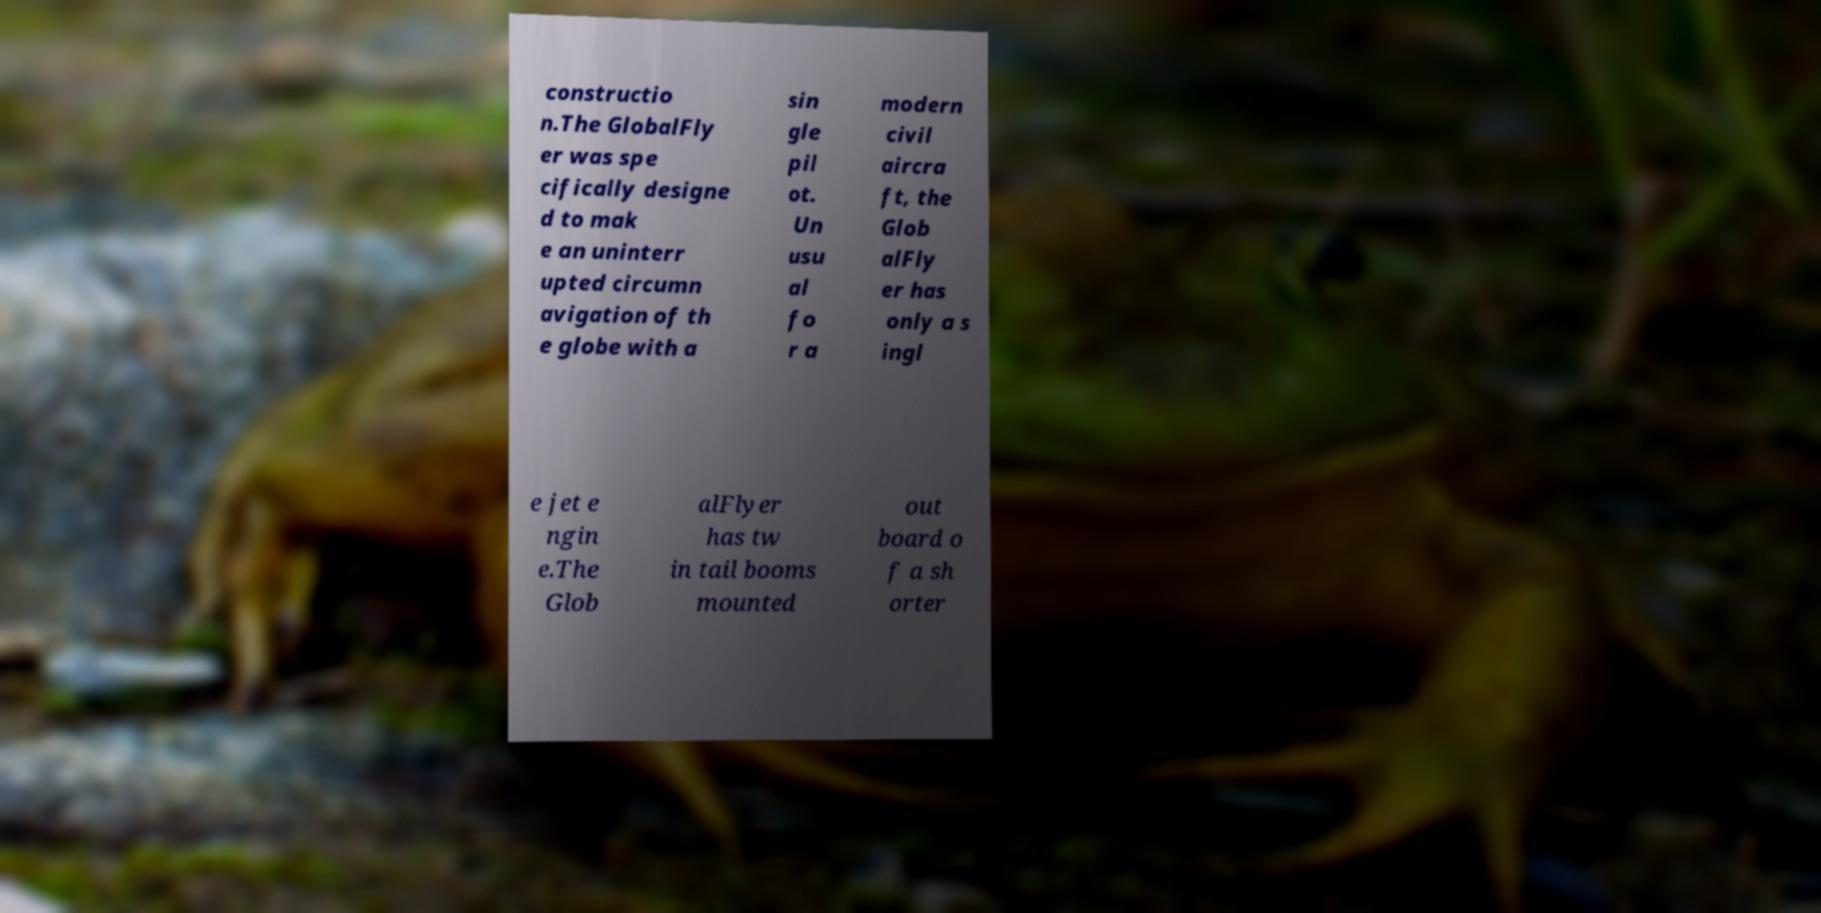I need the written content from this picture converted into text. Can you do that? constructio n.The GlobalFly er was spe cifically designe d to mak e an uninterr upted circumn avigation of th e globe with a sin gle pil ot. Un usu al fo r a modern civil aircra ft, the Glob alFly er has only a s ingl e jet e ngin e.The Glob alFlyer has tw in tail booms mounted out board o f a sh orter 